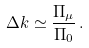<formula> <loc_0><loc_0><loc_500><loc_500>\Delta k \simeq \frac { \Pi _ { \mu } } { \Pi _ { 0 } } \, { . }</formula> 